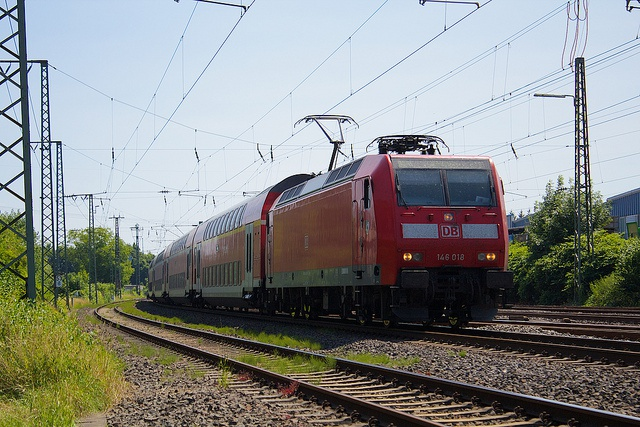Describe the objects in this image and their specific colors. I can see a train in lightblue, black, maroon, gray, and darkgray tones in this image. 